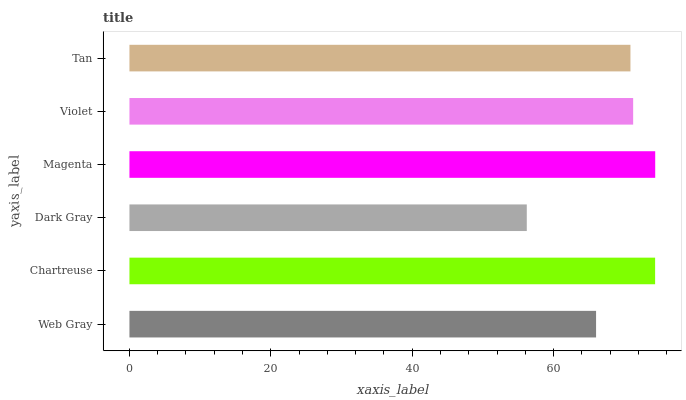Is Dark Gray the minimum?
Answer yes or no. Yes. Is Magenta the maximum?
Answer yes or no. Yes. Is Chartreuse the minimum?
Answer yes or no. No. Is Chartreuse the maximum?
Answer yes or no. No. Is Chartreuse greater than Web Gray?
Answer yes or no. Yes. Is Web Gray less than Chartreuse?
Answer yes or no. Yes. Is Web Gray greater than Chartreuse?
Answer yes or no. No. Is Chartreuse less than Web Gray?
Answer yes or no. No. Is Violet the high median?
Answer yes or no. Yes. Is Tan the low median?
Answer yes or no. Yes. Is Magenta the high median?
Answer yes or no. No. Is Web Gray the low median?
Answer yes or no. No. 